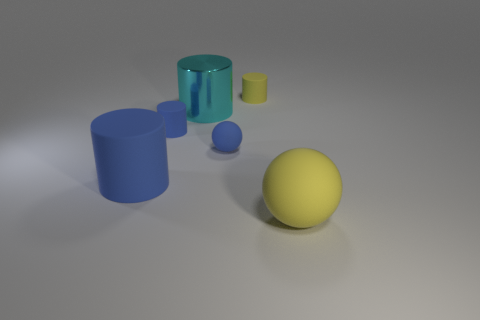How many blue things have the same size as the cyan shiny object?
Your answer should be compact. 1. There is a large thing that is the same color as the small rubber ball; what is its shape?
Your answer should be very brief. Cylinder. What material is the big cylinder behind the large blue thing?
Your response must be concise. Metal. What number of yellow matte objects have the same shape as the metallic object?
Provide a succinct answer. 1. The big blue thing that is made of the same material as the small yellow thing is what shape?
Your answer should be very brief. Cylinder. The large rubber object that is on the left side of the matte object that is to the right of the matte cylinder behind the cyan object is what shape?
Your answer should be very brief. Cylinder. Is the number of blue things greater than the number of rubber things?
Your response must be concise. No. There is a cyan object that is the same shape as the tiny yellow object; what is it made of?
Provide a short and direct response. Metal. Are the big blue thing and the cyan cylinder made of the same material?
Provide a short and direct response. No. Is the number of large blue matte cylinders that are left of the yellow rubber cylinder greater than the number of blue shiny balls?
Offer a terse response. Yes. 